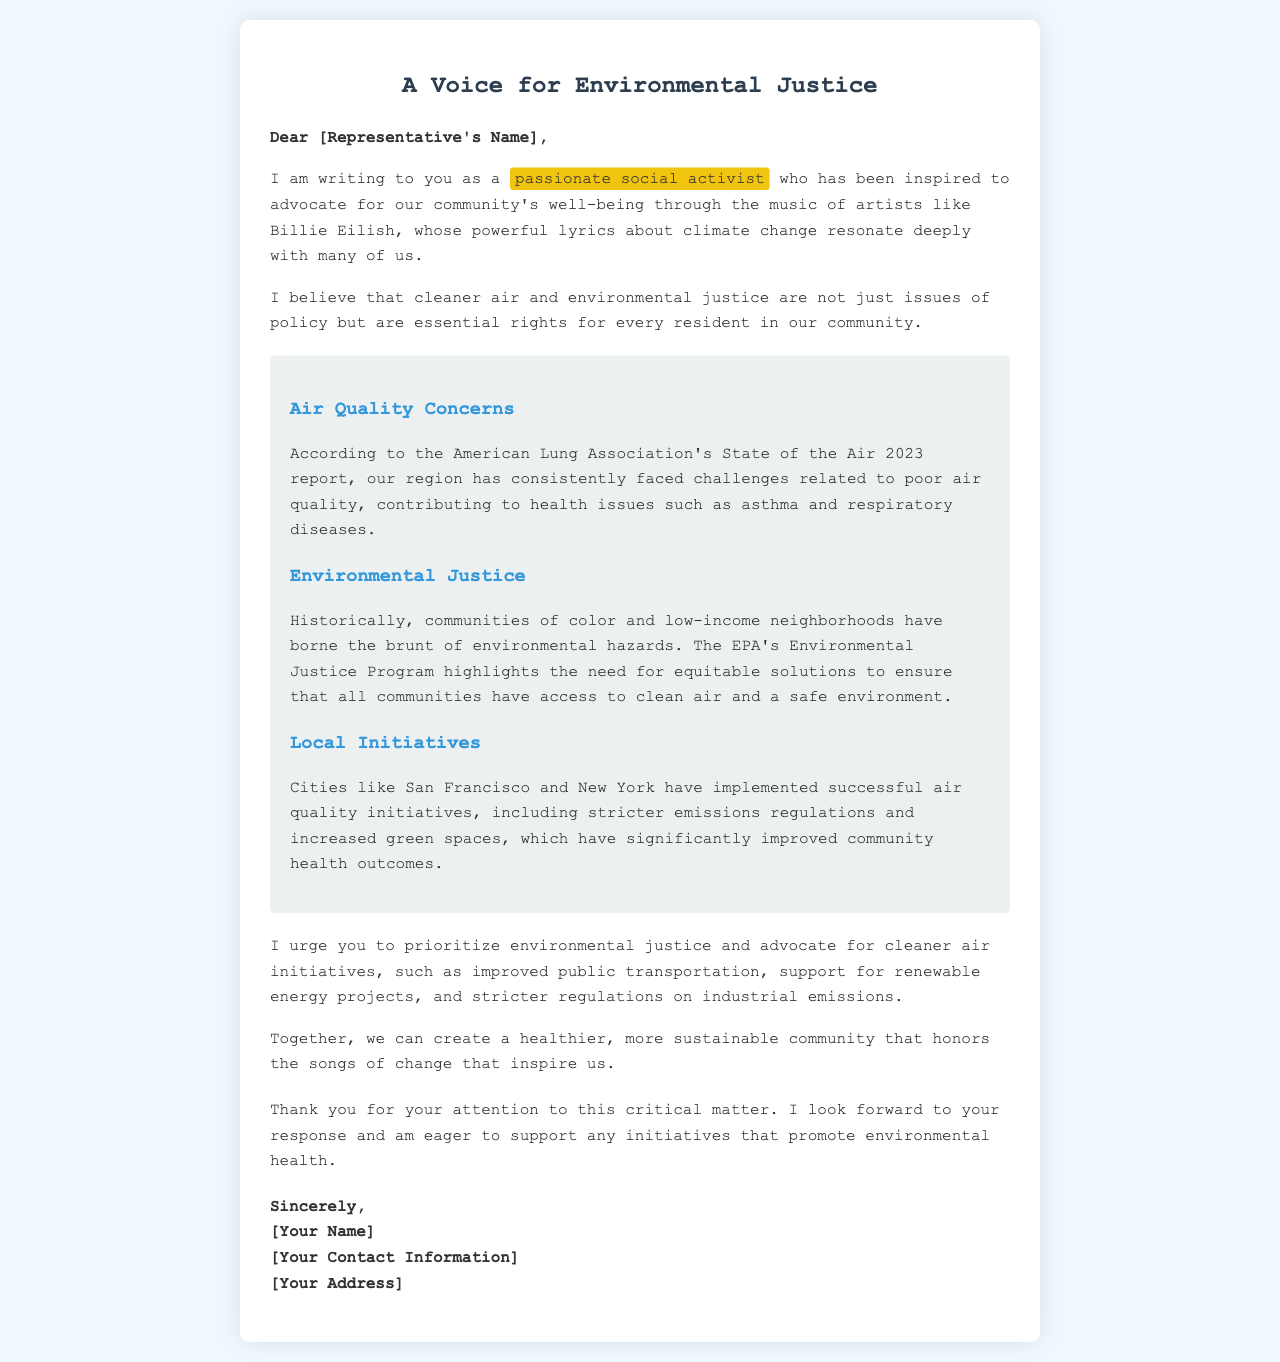What is the name of the letter? The title of the letter is indicated at the top of the document, stating the purpose of the communication.
Answer: A Voice for Environmental Justice Who is the writer inspired by? The letter mentions a specific artist whose music has inspired the writer's activism.
Answer: Billie Eilish What organization released the "State of the Air 2023" report? The letter references a particular organization that reported on air quality issues in the region.
Answer: American Lung Association What major cities are cited as examples of successful air quality initiatives? The document gives examples of two cities demonstrating effective policies for air quality improvements.
Answer: San Francisco and New York What is one suggested initiative for improving air quality mentioned in the letter? The letter provides specific recommendations for actions to enhance environmental health in the community.
Answer: Improved public transportation What issue is highlighted as affecting communities of color and low-income neighborhoods? The letter states a particular challenge faced by certain demographics regarding the environment.
Answer: Environmental hazards What is the main call to action in the letter? The letter concludes with a specific request directed towards the representative regarding a topic of urgency.
Answer: Prioritize environmental justice What does the writer expect from the representative following the letter? The conclusion of the letter indicates what the writer hopes to receive in response to the advocacy effort.
Answer: A response 